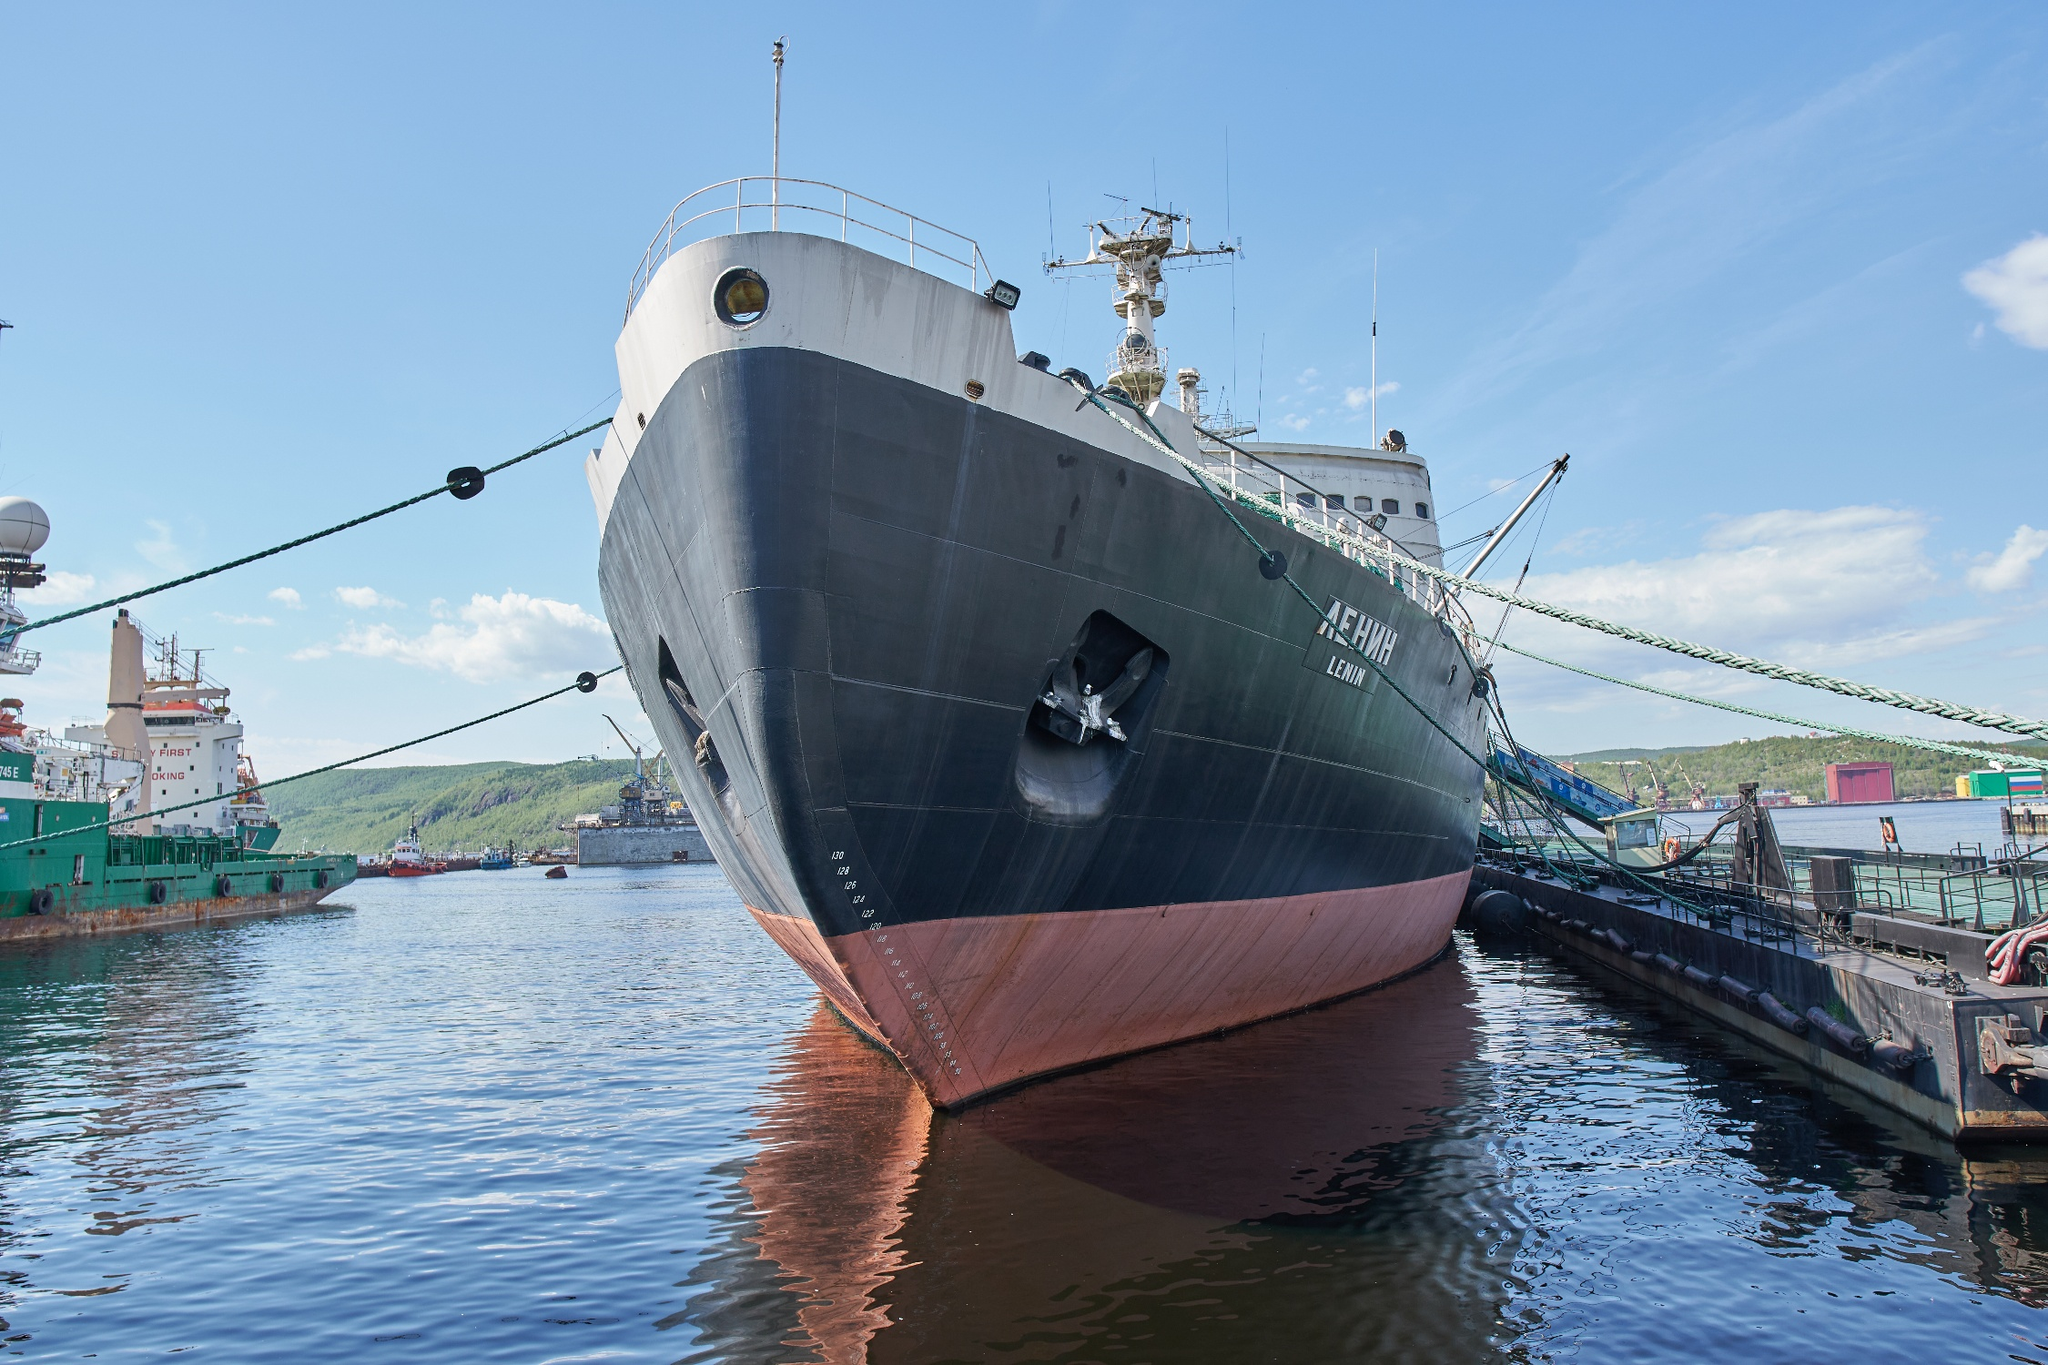What can you tell me about the history of this ship? The ship in the image is the 'Lenin,' a historical Russian icebreaker. Launched in 1957, it holds the distinction of being the world's first nuclear-powered surface ship. The Lenin was designed to navigate the challenging icy waters of the Arctic Ocean and played a crucial role in opening up the Northern Sea Route, making it highly significant for maritime history. The ship operated successfully for several decades before being decommissioned and turned into a museum ship in Murmansk, where it now serves as a reminder of the advancements in icebreaker technology and the bold endeavors of maritime exploration. 